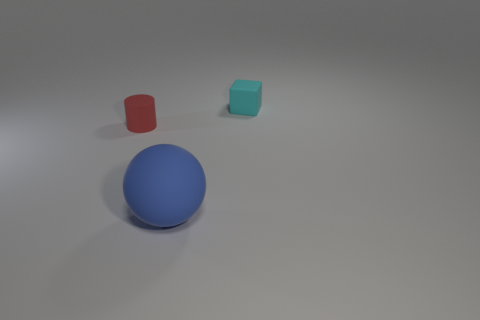The small thing to the right of the rubber object that is in front of the small cylinder to the left of the blue matte thing is made of what material? Based on the image, it appears there is no distinct 'small thing' to the right of the rubber object, which in this context is the red cylinder, located directly in front of the small blue sphere to the left of the turquoise cube. The question may be based on a misunderstanding of the objects' placement and composition in the image. If you mean the turquoise cube when referring to the 'small thing,' then it seems to have a matte surface similar to the blue sphere, hinting it might be made from a similar plastic or painted material. 